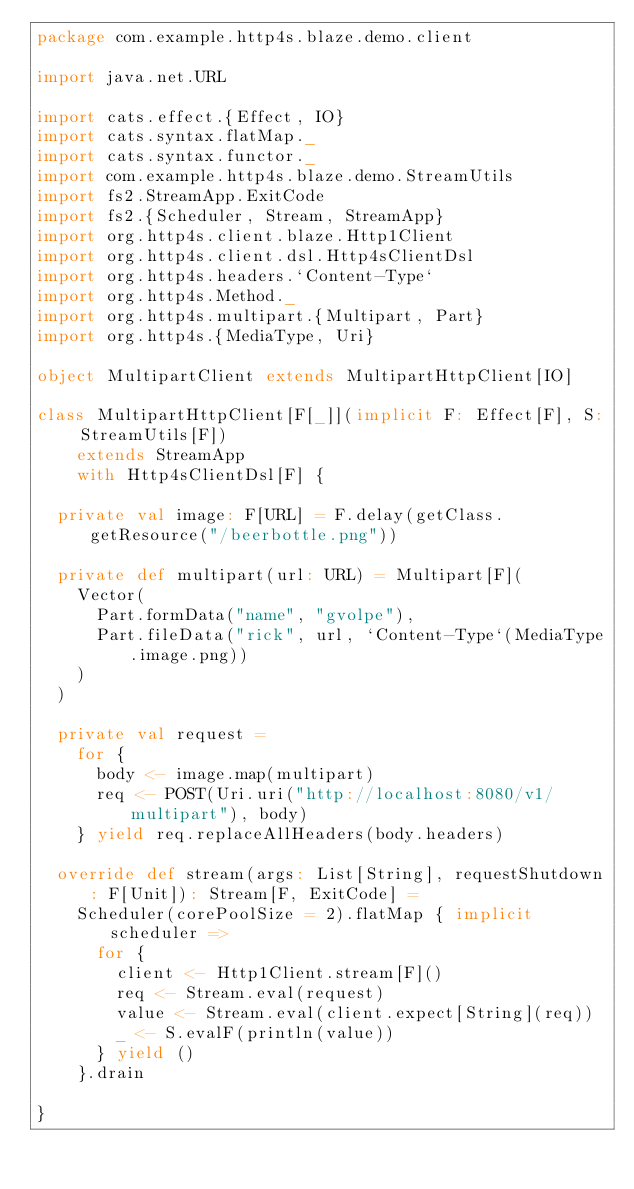Convert code to text. <code><loc_0><loc_0><loc_500><loc_500><_Scala_>package com.example.http4s.blaze.demo.client

import java.net.URL

import cats.effect.{Effect, IO}
import cats.syntax.flatMap._
import cats.syntax.functor._
import com.example.http4s.blaze.demo.StreamUtils
import fs2.StreamApp.ExitCode
import fs2.{Scheduler, Stream, StreamApp}
import org.http4s.client.blaze.Http1Client
import org.http4s.client.dsl.Http4sClientDsl
import org.http4s.headers.`Content-Type`
import org.http4s.Method._
import org.http4s.multipart.{Multipart, Part}
import org.http4s.{MediaType, Uri}

object MultipartClient extends MultipartHttpClient[IO]

class MultipartHttpClient[F[_]](implicit F: Effect[F], S: StreamUtils[F])
    extends StreamApp
    with Http4sClientDsl[F] {

  private val image: F[URL] = F.delay(getClass.getResource("/beerbottle.png"))

  private def multipart(url: URL) = Multipart[F](
    Vector(
      Part.formData("name", "gvolpe"),
      Part.fileData("rick", url, `Content-Type`(MediaType.image.png))
    )
  )

  private val request =
    for {
      body <- image.map(multipart)
      req <- POST(Uri.uri("http://localhost:8080/v1/multipart"), body)
    } yield req.replaceAllHeaders(body.headers)

  override def stream(args: List[String], requestShutdown: F[Unit]): Stream[F, ExitCode] =
    Scheduler(corePoolSize = 2).flatMap { implicit scheduler =>
      for {
        client <- Http1Client.stream[F]()
        req <- Stream.eval(request)
        value <- Stream.eval(client.expect[String](req))
        _ <- S.evalF(println(value))
      } yield ()
    }.drain

}
</code> 